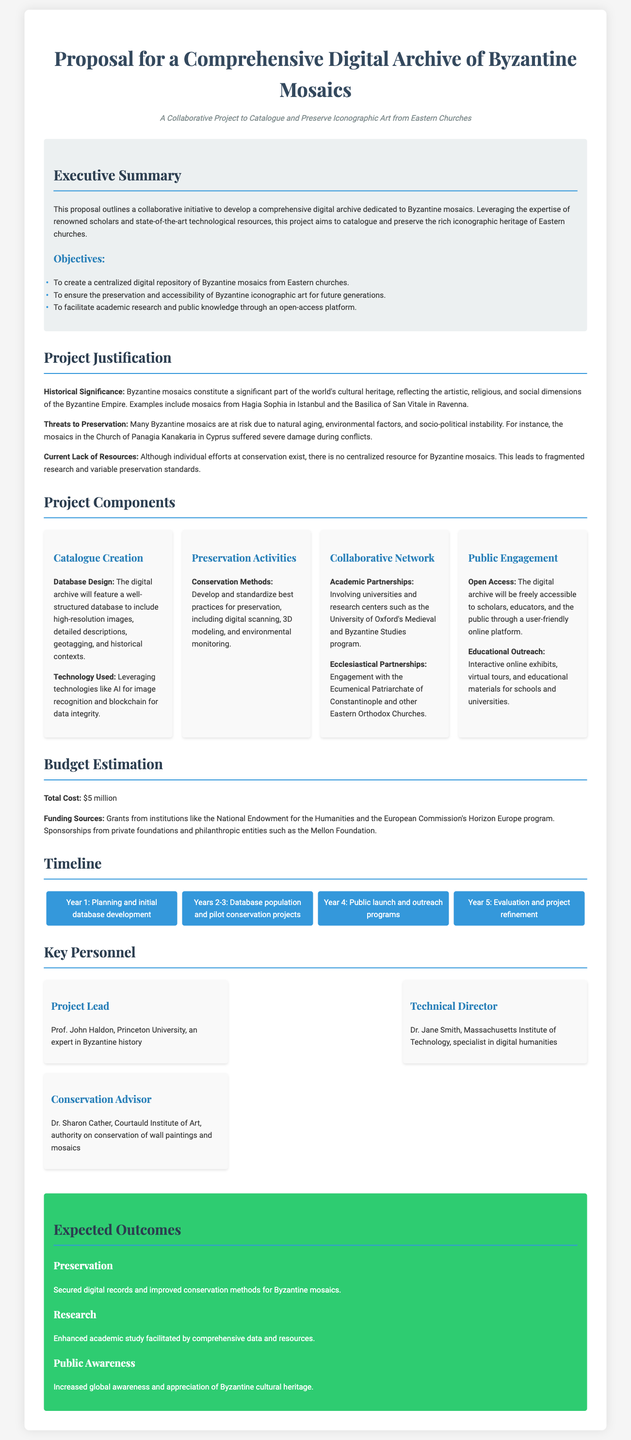What is the title of the proposal? The title of the proposal is the main heading presented at the beginning of the document.
Answer: Proposal for a Comprehensive Digital Archive of Byzantine Mosaics Who is the Project Lead? The Project Lead is mentioned under the Key Personnel section of the document.
Answer: Prof. John Haldon What is the total cost of the project? The total cost is provided in the Budget Estimation section.
Answer: $5 million What years are allocated for database population and pilot conservation projects? The timeline specifies the duration for this phase under Project Timeline.
Answer: Years 2-3 What is the funding source mentioned in the document? The document specifies funding sources under the Budget Estimation section.
Answer: Grants from institutions like the National Endowment for the Humanities What digital technology is mentioned for image recognition? The technology is listed as part of the Catalogue Creation component.
Answer: AI How many key personnel are listed in the proposal? The number of key personnel can be counted in the Key Personnel section.
Answer: 3 What is one of the expected outcomes regarding public awareness? The expected outcome for public awareness is stated in the Expected Outcomes section.
Answer: Increased global awareness and appreciation of Byzantine cultural heritage 